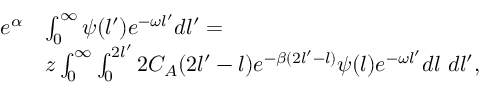Convert formula to latex. <formula><loc_0><loc_0><loc_500><loc_500>\begin{array} { r l } { e ^ { \alpha } } & { \int _ { 0 } ^ { \infty } \psi ( l ^ { \prime } ) e ^ { - \omega l ^ { \prime } } d l ^ { \prime } = } \\ & { z \int _ { 0 } ^ { \infty } \int _ { 0 } ^ { 2 l ^ { \prime } } 2 C _ { A } ( 2 l ^ { \prime } - l ) e ^ { - \beta ( 2 l ^ { \prime } - l ) } \psi ( l ) e ^ { - \omega l ^ { \prime } } d l \ d l ^ { \prime } , } \end{array}</formula> 